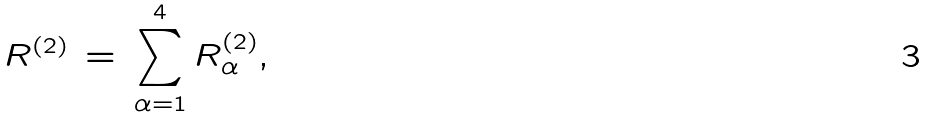Convert formula to latex. <formula><loc_0><loc_0><loc_500><loc_500>R ^ { ( 2 ) } \, = \, \sum _ { \alpha = 1 } ^ { 4 } R _ { \alpha } ^ { ( 2 ) } ,</formula> 